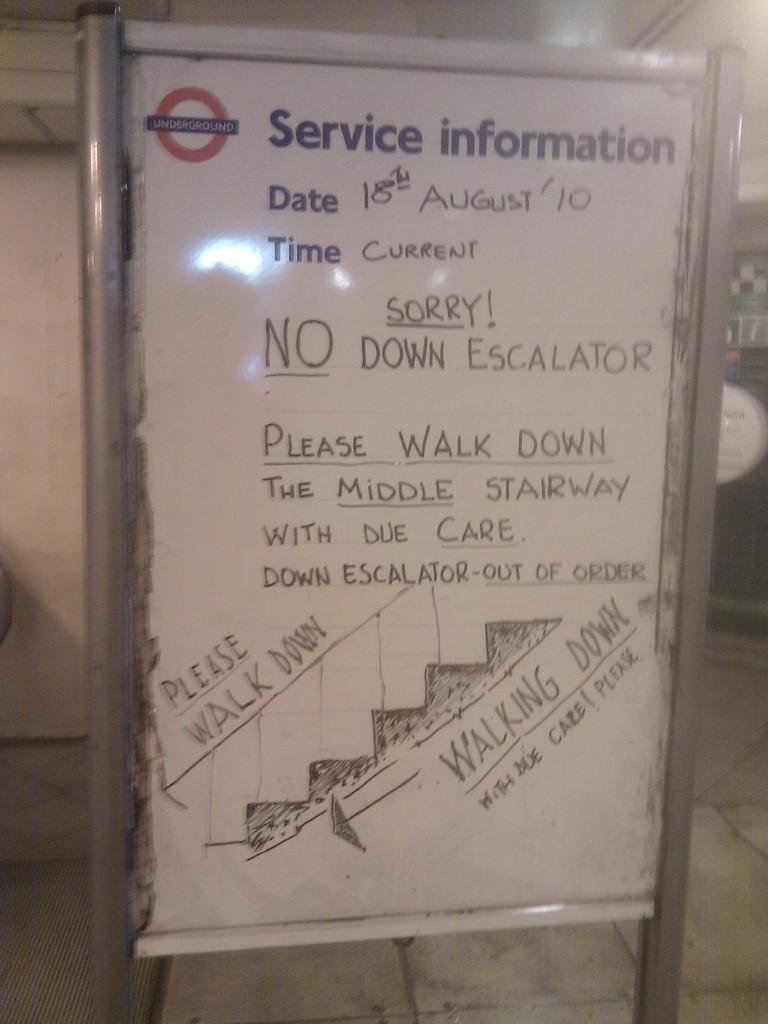What is the main object in the middle of the image? There is a board in the middle of the image. What can be seen on the board? Text is written on the board. Is the board hot to the touch in the image? There is no information about the temperature of the board in the image, so we cannot determine if it is hot or not. Can you see popcorn on the board in the image? There is no mention of popcorn in the image, so we cannot determine if it is present or not. 